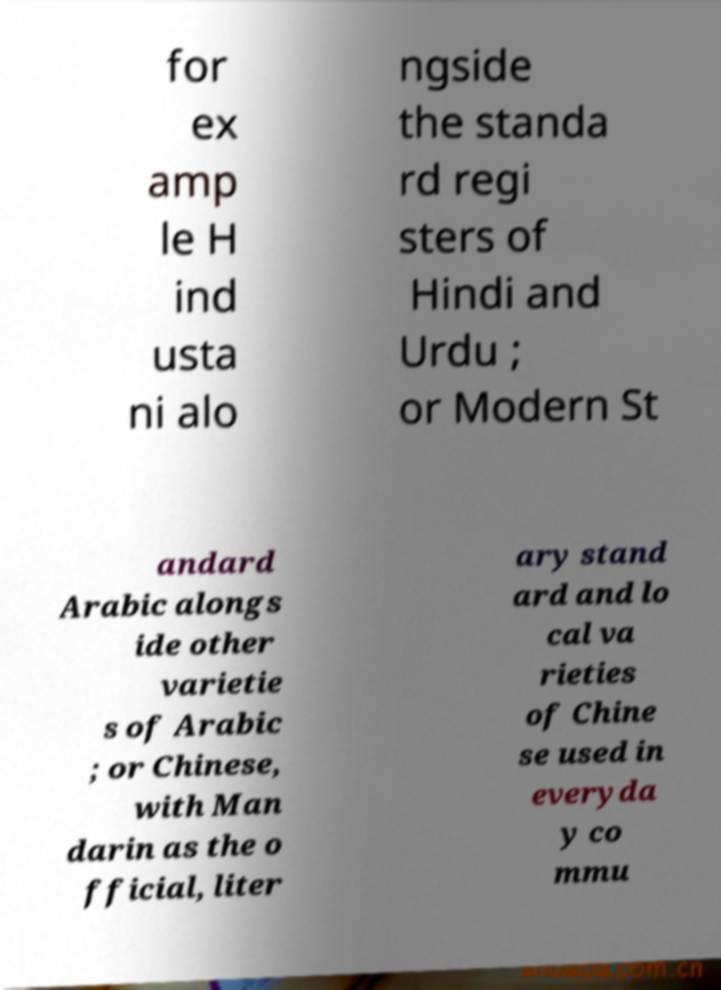What messages or text are displayed in this image? I need them in a readable, typed format. for ex amp le H ind usta ni alo ngside the standa rd regi sters of Hindi and Urdu ; or Modern St andard Arabic alongs ide other varietie s of Arabic ; or Chinese, with Man darin as the o fficial, liter ary stand ard and lo cal va rieties of Chine se used in everyda y co mmu 